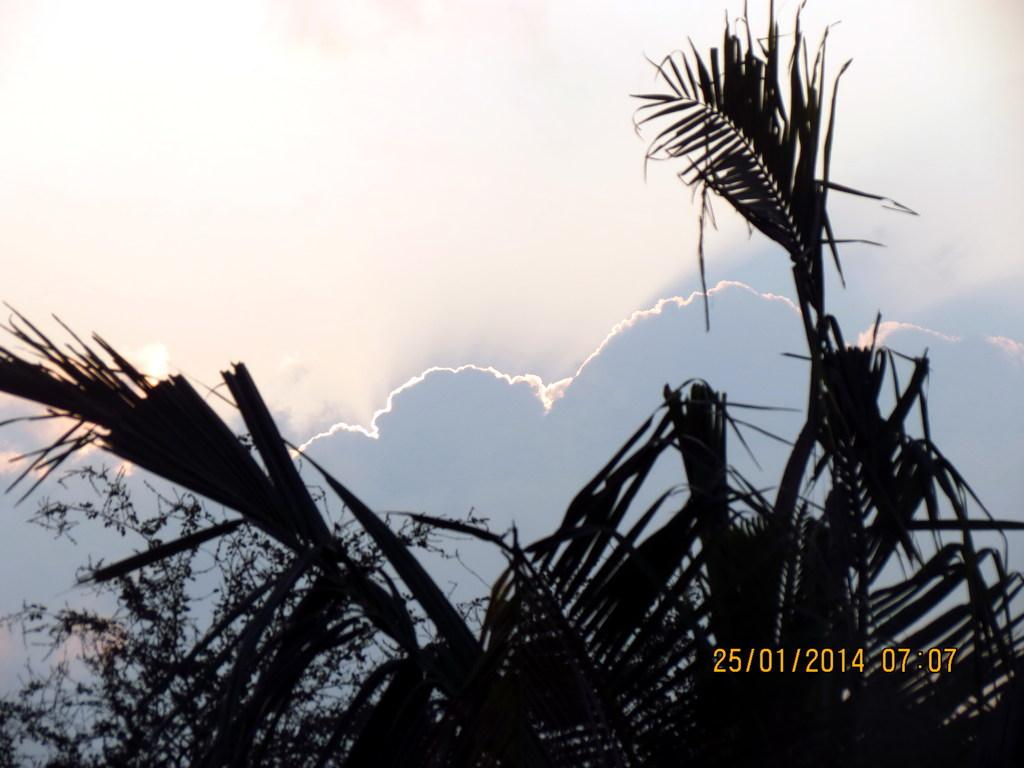What type of vegetation can be seen in the image? There are trees in the image. What is visible in the background of the image? The sky is visible in the background of the image. What can be observed in the sky? Clouds are present in the sky. Is there any information about the date and time in the image? Yes, there is a date and time displayed in the right corner of the image. How many mice are sitting on the stone in the image? There is no stone or mice present in the image. 